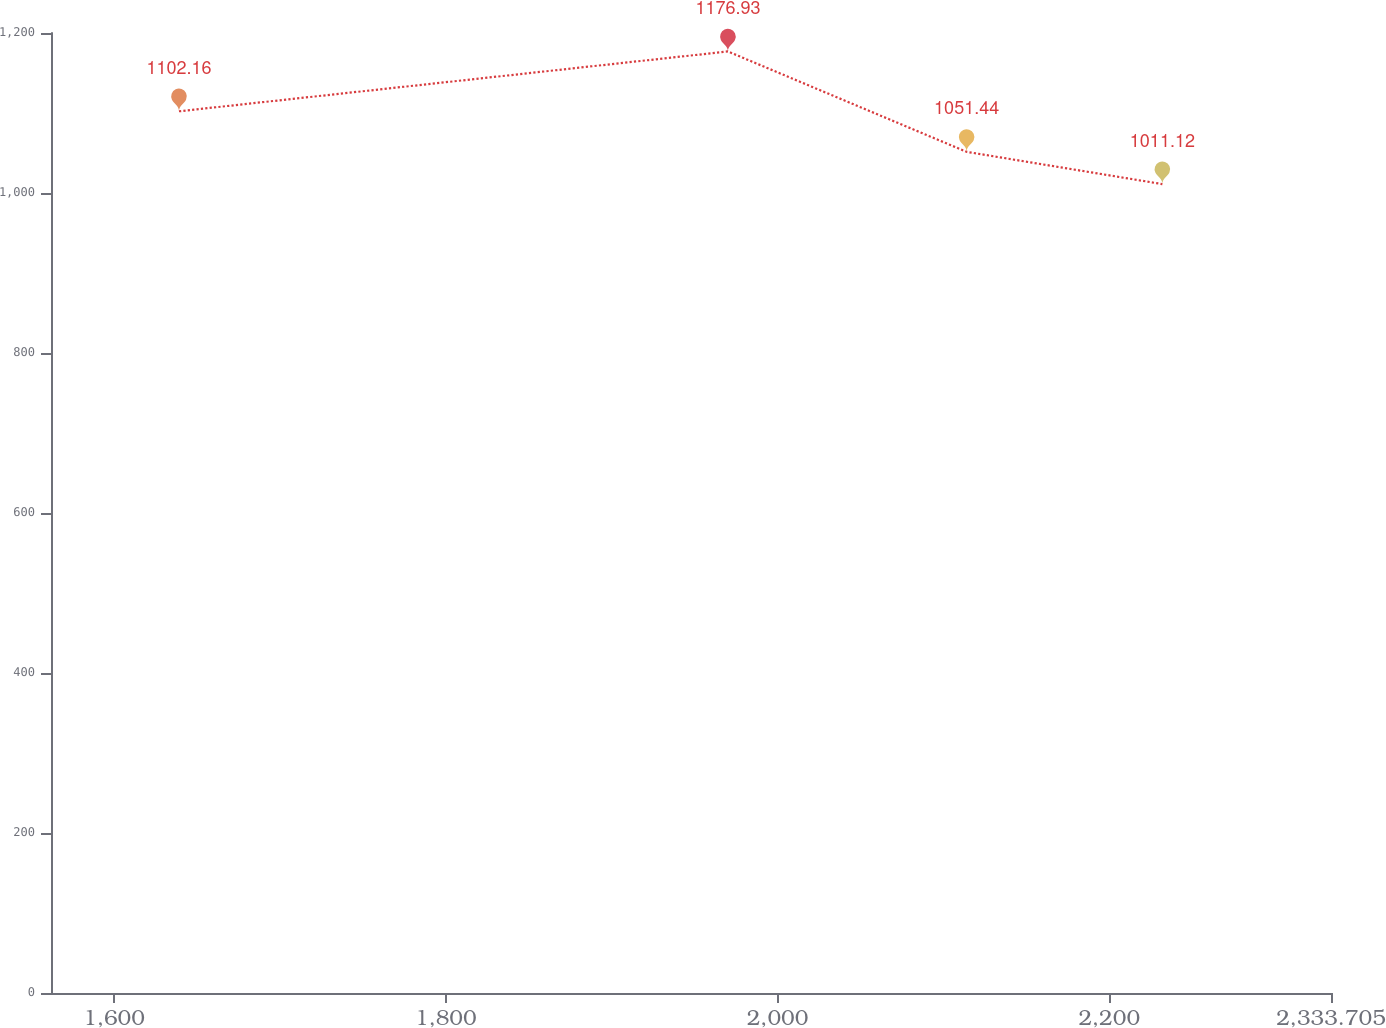<chart> <loc_0><loc_0><loc_500><loc_500><line_chart><ecel><fcel>In millions of dollars<nl><fcel>1639.13<fcel>1102.16<nl><fcel>1970.09<fcel>1176.93<nl><fcel>2114.02<fcel>1051.44<nl><fcel>2232.04<fcel>1011.12<nl><fcel>2410.88<fcel>890.89<nl></chart> 